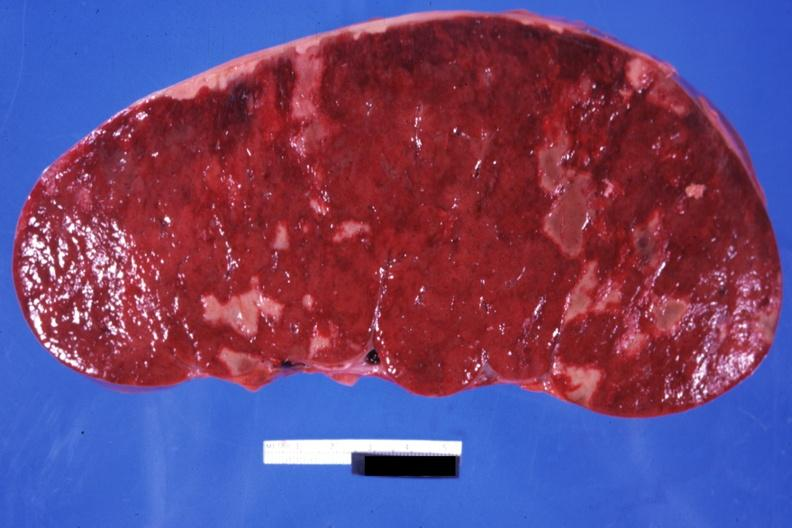s infiltrative process easily seen?
Answer the question using a single word or phrase. Yes 